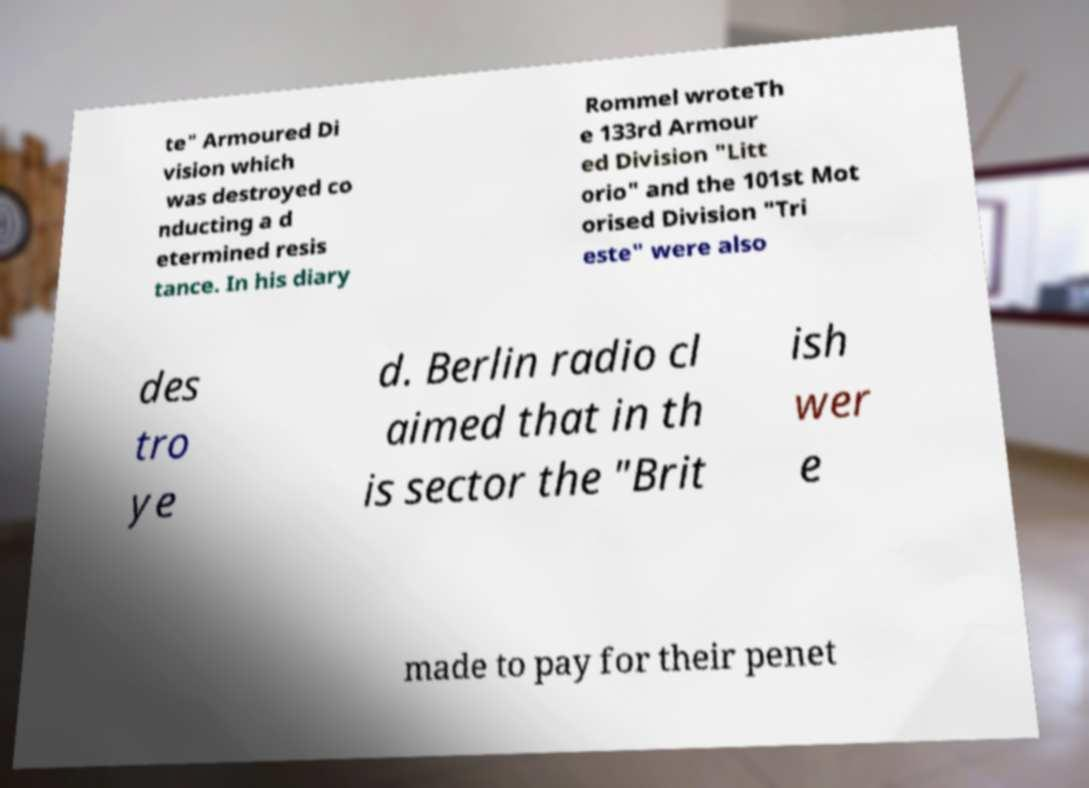For documentation purposes, I need the text within this image transcribed. Could you provide that? te" Armoured Di vision which was destroyed co nducting a d etermined resis tance. In his diary Rommel wroteTh e 133rd Armour ed Division "Litt orio" and the 101st Mot orised Division "Tri este" were also des tro ye d. Berlin radio cl aimed that in th is sector the "Brit ish wer e made to pay for their penet 